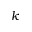Convert formula to latex. <formula><loc_0><loc_0><loc_500><loc_500>k</formula> 